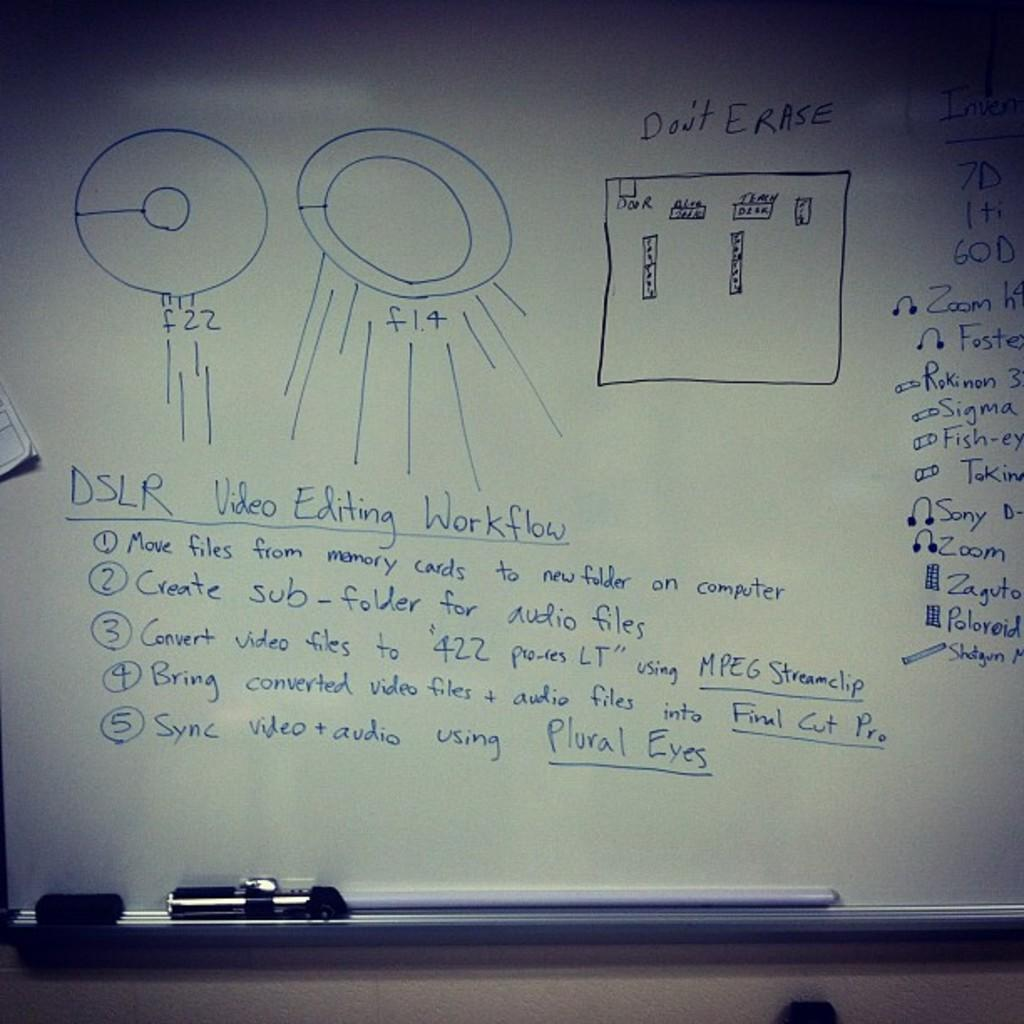<image>
Give a short and clear explanation of the subsequent image. Notes written on a whiteboard about DSLR Video Editing Workflow. 